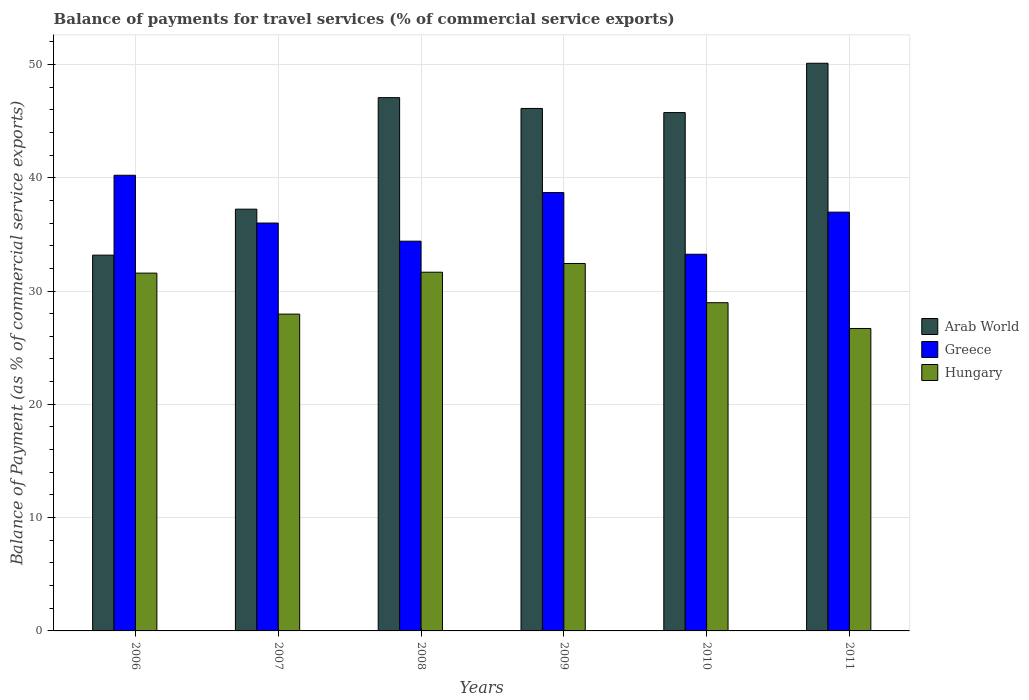How many different coloured bars are there?
Provide a short and direct response. 3. How many groups of bars are there?
Keep it short and to the point. 6. Are the number of bars per tick equal to the number of legend labels?
Make the answer very short. Yes. Are the number of bars on each tick of the X-axis equal?
Offer a very short reply. Yes. How many bars are there on the 5th tick from the left?
Make the answer very short. 3. How many bars are there on the 4th tick from the right?
Provide a short and direct response. 3. What is the label of the 6th group of bars from the left?
Provide a succinct answer. 2011. In how many cases, is the number of bars for a given year not equal to the number of legend labels?
Make the answer very short. 0. What is the balance of payments for travel services in Arab World in 2007?
Your response must be concise. 37.22. Across all years, what is the maximum balance of payments for travel services in Greece?
Your response must be concise. 40.22. Across all years, what is the minimum balance of payments for travel services in Hungary?
Offer a very short reply. 26.69. In which year was the balance of payments for travel services in Arab World maximum?
Provide a succinct answer. 2011. In which year was the balance of payments for travel services in Greece minimum?
Offer a terse response. 2010. What is the total balance of payments for travel services in Greece in the graph?
Offer a very short reply. 219.51. What is the difference between the balance of payments for travel services in Arab World in 2009 and that in 2010?
Keep it short and to the point. 0.37. What is the difference between the balance of payments for travel services in Hungary in 2010 and the balance of payments for travel services in Greece in 2006?
Ensure brevity in your answer.  -11.25. What is the average balance of payments for travel services in Greece per year?
Your answer should be very brief. 36.58. In the year 2009, what is the difference between the balance of payments for travel services in Hungary and balance of payments for travel services in Greece?
Provide a short and direct response. -6.26. In how many years, is the balance of payments for travel services in Greece greater than 4 %?
Your response must be concise. 6. What is the ratio of the balance of payments for travel services in Hungary in 2008 to that in 2011?
Make the answer very short. 1.19. Is the difference between the balance of payments for travel services in Hungary in 2007 and 2011 greater than the difference between the balance of payments for travel services in Greece in 2007 and 2011?
Your answer should be very brief. Yes. What is the difference between the highest and the second highest balance of payments for travel services in Arab World?
Offer a terse response. 3.03. What is the difference between the highest and the lowest balance of payments for travel services in Arab World?
Ensure brevity in your answer.  16.94. In how many years, is the balance of payments for travel services in Hungary greater than the average balance of payments for travel services in Hungary taken over all years?
Keep it short and to the point. 3. Is the sum of the balance of payments for travel services in Arab World in 2008 and 2010 greater than the maximum balance of payments for travel services in Hungary across all years?
Offer a terse response. Yes. What does the 3rd bar from the left in 2010 represents?
Keep it short and to the point. Hungary. What does the 3rd bar from the right in 2011 represents?
Your answer should be very brief. Arab World. How many bars are there?
Offer a terse response. 18. Are all the bars in the graph horizontal?
Offer a very short reply. No. What is the difference between two consecutive major ticks on the Y-axis?
Keep it short and to the point. 10. Are the values on the major ticks of Y-axis written in scientific E-notation?
Ensure brevity in your answer.  No. Does the graph contain any zero values?
Ensure brevity in your answer.  No. Does the graph contain grids?
Offer a terse response. Yes. What is the title of the graph?
Keep it short and to the point. Balance of payments for travel services (% of commercial service exports). What is the label or title of the Y-axis?
Offer a terse response. Balance of Payment (as % of commercial service exports). What is the Balance of Payment (as % of commercial service exports) in Arab World in 2006?
Your answer should be compact. 33.17. What is the Balance of Payment (as % of commercial service exports) of Greece in 2006?
Keep it short and to the point. 40.22. What is the Balance of Payment (as % of commercial service exports) in Hungary in 2006?
Your response must be concise. 31.58. What is the Balance of Payment (as % of commercial service exports) in Arab World in 2007?
Your answer should be compact. 37.22. What is the Balance of Payment (as % of commercial service exports) of Greece in 2007?
Offer a very short reply. 36. What is the Balance of Payment (as % of commercial service exports) in Hungary in 2007?
Keep it short and to the point. 27.96. What is the Balance of Payment (as % of commercial service exports) in Arab World in 2008?
Provide a short and direct response. 47.07. What is the Balance of Payment (as % of commercial service exports) in Greece in 2008?
Your response must be concise. 34.4. What is the Balance of Payment (as % of commercial service exports) in Hungary in 2008?
Make the answer very short. 31.66. What is the Balance of Payment (as % of commercial service exports) of Arab World in 2009?
Give a very brief answer. 46.11. What is the Balance of Payment (as % of commercial service exports) in Greece in 2009?
Your answer should be very brief. 38.69. What is the Balance of Payment (as % of commercial service exports) in Hungary in 2009?
Offer a terse response. 32.43. What is the Balance of Payment (as % of commercial service exports) of Arab World in 2010?
Offer a terse response. 45.75. What is the Balance of Payment (as % of commercial service exports) in Greece in 2010?
Provide a succinct answer. 33.25. What is the Balance of Payment (as % of commercial service exports) in Hungary in 2010?
Provide a succinct answer. 28.97. What is the Balance of Payment (as % of commercial service exports) in Arab World in 2011?
Ensure brevity in your answer.  50.1. What is the Balance of Payment (as % of commercial service exports) in Greece in 2011?
Offer a terse response. 36.96. What is the Balance of Payment (as % of commercial service exports) in Hungary in 2011?
Provide a succinct answer. 26.69. Across all years, what is the maximum Balance of Payment (as % of commercial service exports) of Arab World?
Provide a short and direct response. 50.1. Across all years, what is the maximum Balance of Payment (as % of commercial service exports) of Greece?
Your response must be concise. 40.22. Across all years, what is the maximum Balance of Payment (as % of commercial service exports) of Hungary?
Offer a very short reply. 32.43. Across all years, what is the minimum Balance of Payment (as % of commercial service exports) in Arab World?
Ensure brevity in your answer.  33.17. Across all years, what is the minimum Balance of Payment (as % of commercial service exports) of Greece?
Give a very brief answer. 33.25. Across all years, what is the minimum Balance of Payment (as % of commercial service exports) in Hungary?
Ensure brevity in your answer.  26.69. What is the total Balance of Payment (as % of commercial service exports) of Arab World in the graph?
Provide a succinct answer. 259.42. What is the total Balance of Payment (as % of commercial service exports) in Greece in the graph?
Your response must be concise. 219.51. What is the total Balance of Payment (as % of commercial service exports) in Hungary in the graph?
Offer a very short reply. 179.29. What is the difference between the Balance of Payment (as % of commercial service exports) of Arab World in 2006 and that in 2007?
Your answer should be compact. -4.06. What is the difference between the Balance of Payment (as % of commercial service exports) in Greece in 2006 and that in 2007?
Offer a terse response. 4.22. What is the difference between the Balance of Payment (as % of commercial service exports) in Hungary in 2006 and that in 2007?
Provide a succinct answer. 3.62. What is the difference between the Balance of Payment (as % of commercial service exports) of Arab World in 2006 and that in 2008?
Ensure brevity in your answer.  -13.9. What is the difference between the Balance of Payment (as % of commercial service exports) of Greece in 2006 and that in 2008?
Offer a terse response. 5.82. What is the difference between the Balance of Payment (as % of commercial service exports) of Hungary in 2006 and that in 2008?
Provide a succinct answer. -0.08. What is the difference between the Balance of Payment (as % of commercial service exports) in Arab World in 2006 and that in 2009?
Provide a short and direct response. -12.95. What is the difference between the Balance of Payment (as % of commercial service exports) of Greece in 2006 and that in 2009?
Your answer should be very brief. 1.53. What is the difference between the Balance of Payment (as % of commercial service exports) of Hungary in 2006 and that in 2009?
Offer a terse response. -0.85. What is the difference between the Balance of Payment (as % of commercial service exports) in Arab World in 2006 and that in 2010?
Provide a short and direct response. -12.58. What is the difference between the Balance of Payment (as % of commercial service exports) in Greece in 2006 and that in 2010?
Your answer should be very brief. 6.97. What is the difference between the Balance of Payment (as % of commercial service exports) of Hungary in 2006 and that in 2010?
Your response must be concise. 2.61. What is the difference between the Balance of Payment (as % of commercial service exports) of Arab World in 2006 and that in 2011?
Keep it short and to the point. -16.94. What is the difference between the Balance of Payment (as % of commercial service exports) in Greece in 2006 and that in 2011?
Provide a succinct answer. 3.26. What is the difference between the Balance of Payment (as % of commercial service exports) in Hungary in 2006 and that in 2011?
Provide a short and direct response. 4.89. What is the difference between the Balance of Payment (as % of commercial service exports) of Arab World in 2007 and that in 2008?
Give a very brief answer. -9.84. What is the difference between the Balance of Payment (as % of commercial service exports) of Greece in 2007 and that in 2008?
Keep it short and to the point. 1.6. What is the difference between the Balance of Payment (as % of commercial service exports) in Hungary in 2007 and that in 2008?
Ensure brevity in your answer.  -3.7. What is the difference between the Balance of Payment (as % of commercial service exports) of Arab World in 2007 and that in 2009?
Ensure brevity in your answer.  -8.89. What is the difference between the Balance of Payment (as % of commercial service exports) in Greece in 2007 and that in 2009?
Your answer should be compact. -2.69. What is the difference between the Balance of Payment (as % of commercial service exports) in Hungary in 2007 and that in 2009?
Keep it short and to the point. -4.47. What is the difference between the Balance of Payment (as % of commercial service exports) in Arab World in 2007 and that in 2010?
Make the answer very short. -8.52. What is the difference between the Balance of Payment (as % of commercial service exports) in Greece in 2007 and that in 2010?
Provide a succinct answer. 2.75. What is the difference between the Balance of Payment (as % of commercial service exports) of Hungary in 2007 and that in 2010?
Your response must be concise. -1.01. What is the difference between the Balance of Payment (as % of commercial service exports) of Arab World in 2007 and that in 2011?
Your answer should be compact. -12.88. What is the difference between the Balance of Payment (as % of commercial service exports) of Greece in 2007 and that in 2011?
Your answer should be compact. -0.96. What is the difference between the Balance of Payment (as % of commercial service exports) of Hungary in 2007 and that in 2011?
Offer a very short reply. 1.27. What is the difference between the Balance of Payment (as % of commercial service exports) in Arab World in 2008 and that in 2009?
Your response must be concise. 0.95. What is the difference between the Balance of Payment (as % of commercial service exports) of Greece in 2008 and that in 2009?
Your response must be concise. -4.29. What is the difference between the Balance of Payment (as % of commercial service exports) in Hungary in 2008 and that in 2009?
Provide a succinct answer. -0.77. What is the difference between the Balance of Payment (as % of commercial service exports) of Arab World in 2008 and that in 2010?
Offer a very short reply. 1.32. What is the difference between the Balance of Payment (as % of commercial service exports) of Greece in 2008 and that in 2010?
Offer a terse response. 1.15. What is the difference between the Balance of Payment (as % of commercial service exports) of Hungary in 2008 and that in 2010?
Your answer should be very brief. 2.69. What is the difference between the Balance of Payment (as % of commercial service exports) of Arab World in 2008 and that in 2011?
Your answer should be very brief. -3.03. What is the difference between the Balance of Payment (as % of commercial service exports) of Greece in 2008 and that in 2011?
Give a very brief answer. -2.56. What is the difference between the Balance of Payment (as % of commercial service exports) in Hungary in 2008 and that in 2011?
Give a very brief answer. 4.97. What is the difference between the Balance of Payment (as % of commercial service exports) of Arab World in 2009 and that in 2010?
Offer a very short reply. 0.37. What is the difference between the Balance of Payment (as % of commercial service exports) of Greece in 2009 and that in 2010?
Provide a succinct answer. 5.44. What is the difference between the Balance of Payment (as % of commercial service exports) in Hungary in 2009 and that in 2010?
Provide a succinct answer. 3.46. What is the difference between the Balance of Payment (as % of commercial service exports) of Arab World in 2009 and that in 2011?
Your answer should be very brief. -3.99. What is the difference between the Balance of Payment (as % of commercial service exports) in Greece in 2009 and that in 2011?
Keep it short and to the point. 1.73. What is the difference between the Balance of Payment (as % of commercial service exports) of Hungary in 2009 and that in 2011?
Your response must be concise. 5.74. What is the difference between the Balance of Payment (as % of commercial service exports) of Arab World in 2010 and that in 2011?
Your answer should be very brief. -4.35. What is the difference between the Balance of Payment (as % of commercial service exports) in Greece in 2010 and that in 2011?
Offer a terse response. -3.72. What is the difference between the Balance of Payment (as % of commercial service exports) in Hungary in 2010 and that in 2011?
Provide a succinct answer. 2.28. What is the difference between the Balance of Payment (as % of commercial service exports) in Arab World in 2006 and the Balance of Payment (as % of commercial service exports) in Greece in 2007?
Provide a succinct answer. -2.83. What is the difference between the Balance of Payment (as % of commercial service exports) of Arab World in 2006 and the Balance of Payment (as % of commercial service exports) of Hungary in 2007?
Give a very brief answer. 5.2. What is the difference between the Balance of Payment (as % of commercial service exports) in Greece in 2006 and the Balance of Payment (as % of commercial service exports) in Hungary in 2007?
Your answer should be compact. 12.25. What is the difference between the Balance of Payment (as % of commercial service exports) in Arab World in 2006 and the Balance of Payment (as % of commercial service exports) in Greece in 2008?
Provide a succinct answer. -1.23. What is the difference between the Balance of Payment (as % of commercial service exports) in Arab World in 2006 and the Balance of Payment (as % of commercial service exports) in Hungary in 2008?
Keep it short and to the point. 1.51. What is the difference between the Balance of Payment (as % of commercial service exports) of Greece in 2006 and the Balance of Payment (as % of commercial service exports) of Hungary in 2008?
Provide a short and direct response. 8.56. What is the difference between the Balance of Payment (as % of commercial service exports) of Arab World in 2006 and the Balance of Payment (as % of commercial service exports) of Greece in 2009?
Your answer should be very brief. -5.52. What is the difference between the Balance of Payment (as % of commercial service exports) in Arab World in 2006 and the Balance of Payment (as % of commercial service exports) in Hungary in 2009?
Provide a succinct answer. 0.74. What is the difference between the Balance of Payment (as % of commercial service exports) in Greece in 2006 and the Balance of Payment (as % of commercial service exports) in Hungary in 2009?
Keep it short and to the point. 7.79. What is the difference between the Balance of Payment (as % of commercial service exports) in Arab World in 2006 and the Balance of Payment (as % of commercial service exports) in Greece in 2010?
Give a very brief answer. -0.08. What is the difference between the Balance of Payment (as % of commercial service exports) in Arab World in 2006 and the Balance of Payment (as % of commercial service exports) in Hungary in 2010?
Provide a succinct answer. 4.2. What is the difference between the Balance of Payment (as % of commercial service exports) in Greece in 2006 and the Balance of Payment (as % of commercial service exports) in Hungary in 2010?
Keep it short and to the point. 11.25. What is the difference between the Balance of Payment (as % of commercial service exports) of Arab World in 2006 and the Balance of Payment (as % of commercial service exports) of Greece in 2011?
Provide a short and direct response. -3.79. What is the difference between the Balance of Payment (as % of commercial service exports) in Arab World in 2006 and the Balance of Payment (as % of commercial service exports) in Hungary in 2011?
Give a very brief answer. 6.47. What is the difference between the Balance of Payment (as % of commercial service exports) of Greece in 2006 and the Balance of Payment (as % of commercial service exports) of Hungary in 2011?
Your answer should be compact. 13.52. What is the difference between the Balance of Payment (as % of commercial service exports) in Arab World in 2007 and the Balance of Payment (as % of commercial service exports) in Greece in 2008?
Ensure brevity in your answer.  2.83. What is the difference between the Balance of Payment (as % of commercial service exports) in Arab World in 2007 and the Balance of Payment (as % of commercial service exports) in Hungary in 2008?
Your response must be concise. 5.57. What is the difference between the Balance of Payment (as % of commercial service exports) of Greece in 2007 and the Balance of Payment (as % of commercial service exports) of Hungary in 2008?
Give a very brief answer. 4.34. What is the difference between the Balance of Payment (as % of commercial service exports) in Arab World in 2007 and the Balance of Payment (as % of commercial service exports) in Greece in 2009?
Keep it short and to the point. -1.46. What is the difference between the Balance of Payment (as % of commercial service exports) of Arab World in 2007 and the Balance of Payment (as % of commercial service exports) of Hungary in 2009?
Provide a succinct answer. 4.79. What is the difference between the Balance of Payment (as % of commercial service exports) in Greece in 2007 and the Balance of Payment (as % of commercial service exports) in Hungary in 2009?
Give a very brief answer. 3.57. What is the difference between the Balance of Payment (as % of commercial service exports) in Arab World in 2007 and the Balance of Payment (as % of commercial service exports) in Greece in 2010?
Ensure brevity in your answer.  3.98. What is the difference between the Balance of Payment (as % of commercial service exports) in Arab World in 2007 and the Balance of Payment (as % of commercial service exports) in Hungary in 2010?
Provide a short and direct response. 8.26. What is the difference between the Balance of Payment (as % of commercial service exports) of Greece in 2007 and the Balance of Payment (as % of commercial service exports) of Hungary in 2010?
Your answer should be very brief. 7.03. What is the difference between the Balance of Payment (as % of commercial service exports) of Arab World in 2007 and the Balance of Payment (as % of commercial service exports) of Greece in 2011?
Provide a succinct answer. 0.26. What is the difference between the Balance of Payment (as % of commercial service exports) in Arab World in 2007 and the Balance of Payment (as % of commercial service exports) in Hungary in 2011?
Provide a succinct answer. 10.53. What is the difference between the Balance of Payment (as % of commercial service exports) in Greece in 2007 and the Balance of Payment (as % of commercial service exports) in Hungary in 2011?
Your response must be concise. 9.31. What is the difference between the Balance of Payment (as % of commercial service exports) of Arab World in 2008 and the Balance of Payment (as % of commercial service exports) of Greece in 2009?
Offer a very short reply. 8.38. What is the difference between the Balance of Payment (as % of commercial service exports) in Arab World in 2008 and the Balance of Payment (as % of commercial service exports) in Hungary in 2009?
Offer a terse response. 14.64. What is the difference between the Balance of Payment (as % of commercial service exports) in Greece in 2008 and the Balance of Payment (as % of commercial service exports) in Hungary in 2009?
Keep it short and to the point. 1.97. What is the difference between the Balance of Payment (as % of commercial service exports) in Arab World in 2008 and the Balance of Payment (as % of commercial service exports) in Greece in 2010?
Your answer should be compact. 13.82. What is the difference between the Balance of Payment (as % of commercial service exports) of Arab World in 2008 and the Balance of Payment (as % of commercial service exports) of Hungary in 2010?
Your answer should be very brief. 18.1. What is the difference between the Balance of Payment (as % of commercial service exports) in Greece in 2008 and the Balance of Payment (as % of commercial service exports) in Hungary in 2010?
Keep it short and to the point. 5.43. What is the difference between the Balance of Payment (as % of commercial service exports) in Arab World in 2008 and the Balance of Payment (as % of commercial service exports) in Greece in 2011?
Offer a terse response. 10.11. What is the difference between the Balance of Payment (as % of commercial service exports) in Arab World in 2008 and the Balance of Payment (as % of commercial service exports) in Hungary in 2011?
Offer a terse response. 20.37. What is the difference between the Balance of Payment (as % of commercial service exports) of Greece in 2008 and the Balance of Payment (as % of commercial service exports) of Hungary in 2011?
Offer a terse response. 7.71. What is the difference between the Balance of Payment (as % of commercial service exports) of Arab World in 2009 and the Balance of Payment (as % of commercial service exports) of Greece in 2010?
Give a very brief answer. 12.87. What is the difference between the Balance of Payment (as % of commercial service exports) of Arab World in 2009 and the Balance of Payment (as % of commercial service exports) of Hungary in 2010?
Your answer should be compact. 17.14. What is the difference between the Balance of Payment (as % of commercial service exports) in Greece in 2009 and the Balance of Payment (as % of commercial service exports) in Hungary in 2010?
Your answer should be very brief. 9.72. What is the difference between the Balance of Payment (as % of commercial service exports) of Arab World in 2009 and the Balance of Payment (as % of commercial service exports) of Greece in 2011?
Your answer should be very brief. 9.15. What is the difference between the Balance of Payment (as % of commercial service exports) of Arab World in 2009 and the Balance of Payment (as % of commercial service exports) of Hungary in 2011?
Offer a very short reply. 19.42. What is the difference between the Balance of Payment (as % of commercial service exports) in Greece in 2009 and the Balance of Payment (as % of commercial service exports) in Hungary in 2011?
Your answer should be very brief. 11.99. What is the difference between the Balance of Payment (as % of commercial service exports) of Arab World in 2010 and the Balance of Payment (as % of commercial service exports) of Greece in 2011?
Offer a very short reply. 8.79. What is the difference between the Balance of Payment (as % of commercial service exports) in Arab World in 2010 and the Balance of Payment (as % of commercial service exports) in Hungary in 2011?
Make the answer very short. 19.05. What is the difference between the Balance of Payment (as % of commercial service exports) of Greece in 2010 and the Balance of Payment (as % of commercial service exports) of Hungary in 2011?
Provide a succinct answer. 6.55. What is the average Balance of Payment (as % of commercial service exports) of Arab World per year?
Make the answer very short. 43.24. What is the average Balance of Payment (as % of commercial service exports) in Greece per year?
Provide a succinct answer. 36.58. What is the average Balance of Payment (as % of commercial service exports) of Hungary per year?
Make the answer very short. 29.88. In the year 2006, what is the difference between the Balance of Payment (as % of commercial service exports) in Arab World and Balance of Payment (as % of commercial service exports) in Greece?
Your answer should be compact. -7.05. In the year 2006, what is the difference between the Balance of Payment (as % of commercial service exports) of Arab World and Balance of Payment (as % of commercial service exports) of Hungary?
Provide a succinct answer. 1.59. In the year 2006, what is the difference between the Balance of Payment (as % of commercial service exports) of Greece and Balance of Payment (as % of commercial service exports) of Hungary?
Keep it short and to the point. 8.64. In the year 2007, what is the difference between the Balance of Payment (as % of commercial service exports) in Arab World and Balance of Payment (as % of commercial service exports) in Greece?
Your response must be concise. 1.22. In the year 2007, what is the difference between the Balance of Payment (as % of commercial service exports) in Arab World and Balance of Payment (as % of commercial service exports) in Hungary?
Offer a very short reply. 9.26. In the year 2007, what is the difference between the Balance of Payment (as % of commercial service exports) of Greece and Balance of Payment (as % of commercial service exports) of Hungary?
Ensure brevity in your answer.  8.04. In the year 2008, what is the difference between the Balance of Payment (as % of commercial service exports) of Arab World and Balance of Payment (as % of commercial service exports) of Greece?
Ensure brevity in your answer.  12.67. In the year 2008, what is the difference between the Balance of Payment (as % of commercial service exports) in Arab World and Balance of Payment (as % of commercial service exports) in Hungary?
Make the answer very short. 15.41. In the year 2008, what is the difference between the Balance of Payment (as % of commercial service exports) of Greece and Balance of Payment (as % of commercial service exports) of Hungary?
Provide a short and direct response. 2.74. In the year 2009, what is the difference between the Balance of Payment (as % of commercial service exports) in Arab World and Balance of Payment (as % of commercial service exports) in Greece?
Provide a short and direct response. 7.43. In the year 2009, what is the difference between the Balance of Payment (as % of commercial service exports) in Arab World and Balance of Payment (as % of commercial service exports) in Hungary?
Offer a terse response. 13.68. In the year 2009, what is the difference between the Balance of Payment (as % of commercial service exports) in Greece and Balance of Payment (as % of commercial service exports) in Hungary?
Give a very brief answer. 6.26. In the year 2010, what is the difference between the Balance of Payment (as % of commercial service exports) in Arab World and Balance of Payment (as % of commercial service exports) in Greece?
Make the answer very short. 12.5. In the year 2010, what is the difference between the Balance of Payment (as % of commercial service exports) of Arab World and Balance of Payment (as % of commercial service exports) of Hungary?
Ensure brevity in your answer.  16.78. In the year 2010, what is the difference between the Balance of Payment (as % of commercial service exports) of Greece and Balance of Payment (as % of commercial service exports) of Hungary?
Offer a terse response. 4.28. In the year 2011, what is the difference between the Balance of Payment (as % of commercial service exports) in Arab World and Balance of Payment (as % of commercial service exports) in Greece?
Your response must be concise. 13.14. In the year 2011, what is the difference between the Balance of Payment (as % of commercial service exports) in Arab World and Balance of Payment (as % of commercial service exports) in Hungary?
Ensure brevity in your answer.  23.41. In the year 2011, what is the difference between the Balance of Payment (as % of commercial service exports) of Greece and Balance of Payment (as % of commercial service exports) of Hungary?
Make the answer very short. 10.27. What is the ratio of the Balance of Payment (as % of commercial service exports) of Arab World in 2006 to that in 2007?
Offer a terse response. 0.89. What is the ratio of the Balance of Payment (as % of commercial service exports) in Greece in 2006 to that in 2007?
Your answer should be compact. 1.12. What is the ratio of the Balance of Payment (as % of commercial service exports) of Hungary in 2006 to that in 2007?
Your answer should be very brief. 1.13. What is the ratio of the Balance of Payment (as % of commercial service exports) in Arab World in 2006 to that in 2008?
Make the answer very short. 0.7. What is the ratio of the Balance of Payment (as % of commercial service exports) in Greece in 2006 to that in 2008?
Keep it short and to the point. 1.17. What is the ratio of the Balance of Payment (as % of commercial service exports) of Hungary in 2006 to that in 2008?
Give a very brief answer. 1. What is the ratio of the Balance of Payment (as % of commercial service exports) in Arab World in 2006 to that in 2009?
Offer a very short reply. 0.72. What is the ratio of the Balance of Payment (as % of commercial service exports) of Greece in 2006 to that in 2009?
Ensure brevity in your answer.  1.04. What is the ratio of the Balance of Payment (as % of commercial service exports) in Hungary in 2006 to that in 2009?
Your answer should be compact. 0.97. What is the ratio of the Balance of Payment (as % of commercial service exports) of Arab World in 2006 to that in 2010?
Your answer should be compact. 0.72. What is the ratio of the Balance of Payment (as % of commercial service exports) of Greece in 2006 to that in 2010?
Make the answer very short. 1.21. What is the ratio of the Balance of Payment (as % of commercial service exports) in Hungary in 2006 to that in 2010?
Make the answer very short. 1.09. What is the ratio of the Balance of Payment (as % of commercial service exports) of Arab World in 2006 to that in 2011?
Your answer should be very brief. 0.66. What is the ratio of the Balance of Payment (as % of commercial service exports) of Greece in 2006 to that in 2011?
Provide a succinct answer. 1.09. What is the ratio of the Balance of Payment (as % of commercial service exports) in Hungary in 2006 to that in 2011?
Offer a terse response. 1.18. What is the ratio of the Balance of Payment (as % of commercial service exports) of Arab World in 2007 to that in 2008?
Offer a terse response. 0.79. What is the ratio of the Balance of Payment (as % of commercial service exports) of Greece in 2007 to that in 2008?
Your response must be concise. 1.05. What is the ratio of the Balance of Payment (as % of commercial service exports) of Hungary in 2007 to that in 2008?
Make the answer very short. 0.88. What is the ratio of the Balance of Payment (as % of commercial service exports) of Arab World in 2007 to that in 2009?
Keep it short and to the point. 0.81. What is the ratio of the Balance of Payment (as % of commercial service exports) of Greece in 2007 to that in 2009?
Your response must be concise. 0.93. What is the ratio of the Balance of Payment (as % of commercial service exports) in Hungary in 2007 to that in 2009?
Provide a succinct answer. 0.86. What is the ratio of the Balance of Payment (as % of commercial service exports) in Arab World in 2007 to that in 2010?
Your response must be concise. 0.81. What is the ratio of the Balance of Payment (as % of commercial service exports) in Greece in 2007 to that in 2010?
Your answer should be compact. 1.08. What is the ratio of the Balance of Payment (as % of commercial service exports) in Hungary in 2007 to that in 2010?
Offer a very short reply. 0.97. What is the ratio of the Balance of Payment (as % of commercial service exports) in Arab World in 2007 to that in 2011?
Ensure brevity in your answer.  0.74. What is the ratio of the Balance of Payment (as % of commercial service exports) in Greece in 2007 to that in 2011?
Your response must be concise. 0.97. What is the ratio of the Balance of Payment (as % of commercial service exports) in Hungary in 2007 to that in 2011?
Give a very brief answer. 1.05. What is the ratio of the Balance of Payment (as % of commercial service exports) of Arab World in 2008 to that in 2009?
Offer a terse response. 1.02. What is the ratio of the Balance of Payment (as % of commercial service exports) of Greece in 2008 to that in 2009?
Your answer should be compact. 0.89. What is the ratio of the Balance of Payment (as % of commercial service exports) in Hungary in 2008 to that in 2009?
Your answer should be very brief. 0.98. What is the ratio of the Balance of Payment (as % of commercial service exports) of Arab World in 2008 to that in 2010?
Give a very brief answer. 1.03. What is the ratio of the Balance of Payment (as % of commercial service exports) in Greece in 2008 to that in 2010?
Your answer should be very brief. 1.03. What is the ratio of the Balance of Payment (as % of commercial service exports) in Hungary in 2008 to that in 2010?
Give a very brief answer. 1.09. What is the ratio of the Balance of Payment (as % of commercial service exports) of Arab World in 2008 to that in 2011?
Your answer should be very brief. 0.94. What is the ratio of the Balance of Payment (as % of commercial service exports) in Greece in 2008 to that in 2011?
Provide a short and direct response. 0.93. What is the ratio of the Balance of Payment (as % of commercial service exports) in Hungary in 2008 to that in 2011?
Keep it short and to the point. 1.19. What is the ratio of the Balance of Payment (as % of commercial service exports) in Greece in 2009 to that in 2010?
Offer a terse response. 1.16. What is the ratio of the Balance of Payment (as % of commercial service exports) of Hungary in 2009 to that in 2010?
Offer a very short reply. 1.12. What is the ratio of the Balance of Payment (as % of commercial service exports) in Arab World in 2009 to that in 2011?
Make the answer very short. 0.92. What is the ratio of the Balance of Payment (as % of commercial service exports) in Greece in 2009 to that in 2011?
Your answer should be compact. 1.05. What is the ratio of the Balance of Payment (as % of commercial service exports) of Hungary in 2009 to that in 2011?
Keep it short and to the point. 1.21. What is the ratio of the Balance of Payment (as % of commercial service exports) in Arab World in 2010 to that in 2011?
Give a very brief answer. 0.91. What is the ratio of the Balance of Payment (as % of commercial service exports) of Greece in 2010 to that in 2011?
Your answer should be very brief. 0.9. What is the ratio of the Balance of Payment (as % of commercial service exports) of Hungary in 2010 to that in 2011?
Your answer should be very brief. 1.09. What is the difference between the highest and the second highest Balance of Payment (as % of commercial service exports) of Arab World?
Ensure brevity in your answer.  3.03. What is the difference between the highest and the second highest Balance of Payment (as % of commercial service exports) in Greece?
Your answer should be very brief. 1.53. What is the difference between the highest and the second highest Balance of Payment (as % of commercial service exports) in Hungary?
Provide a succinct answer. 0.77. What is the difference between the highest and the lowest Balance of Payment (as % of commercial service exports) in Arab World?
Provide a short and direct response. 16.94. What is the difference between the highest and the lowest Balance of Payment (as % of commercial service exports) in Greece?
Provide a succinct answer. 6.97. What is the difference between the highest and the lowest Balance of Payment (as % of commercial service exports) of Hungary?
Keep it short and to the point. 5.74. 